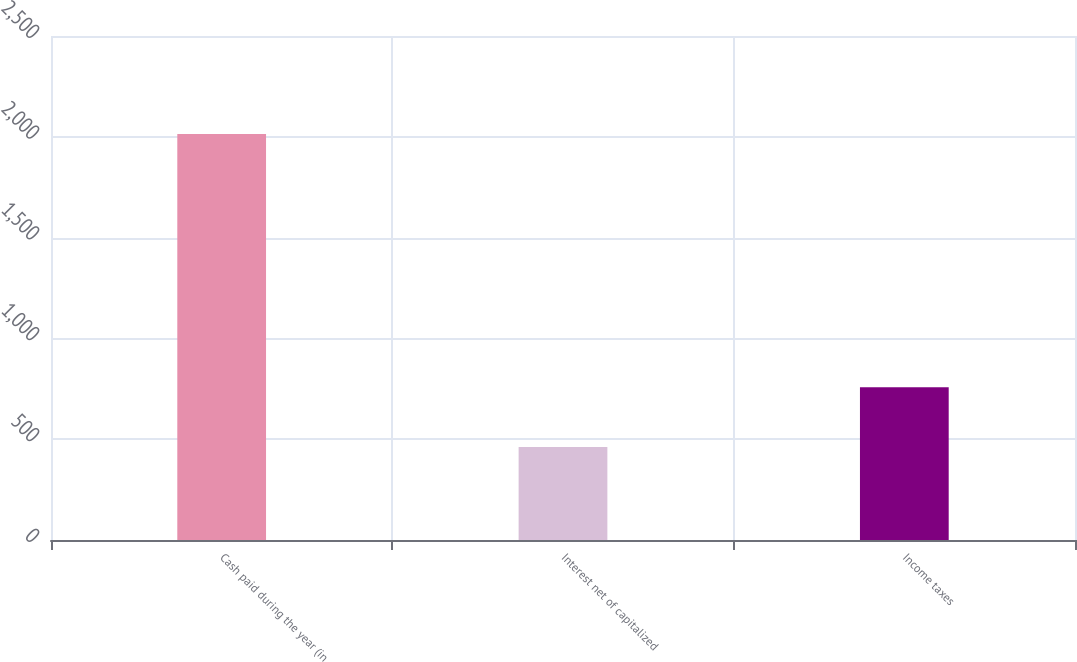Convert chart to OTSL. <chart><loc_0><loc_0><loc_500><loc_500><bar_chart><fcel>Cash paid during the year (in<fcel>Interest net of capitalized<fcel>Income taxes<nl><fcel>2014<fcel>461<fcel>758<nl></chart> 